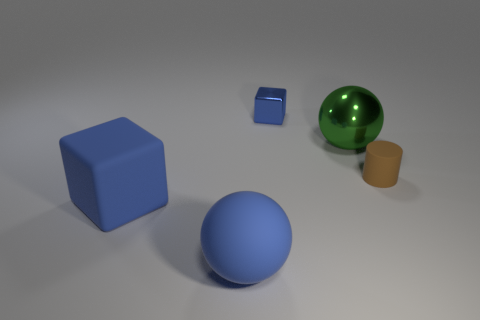Add 1 matte things. How many objects exist? 6 Subtract all cylinders. How many objects are left? 4 Subtract all small cylinders. Subtract all rubber things. How many objects are left? 1 Add 4 blue rubber blocks. How many blue rubber blocks are left? 5 Add 2 small gray balls. How many small gray balls exist? 2 Subtract 0 purple cylinders. How many objects are left? 5 Subtract all yellow blocks. Subtract all green balls. How many blocks are left? 2 